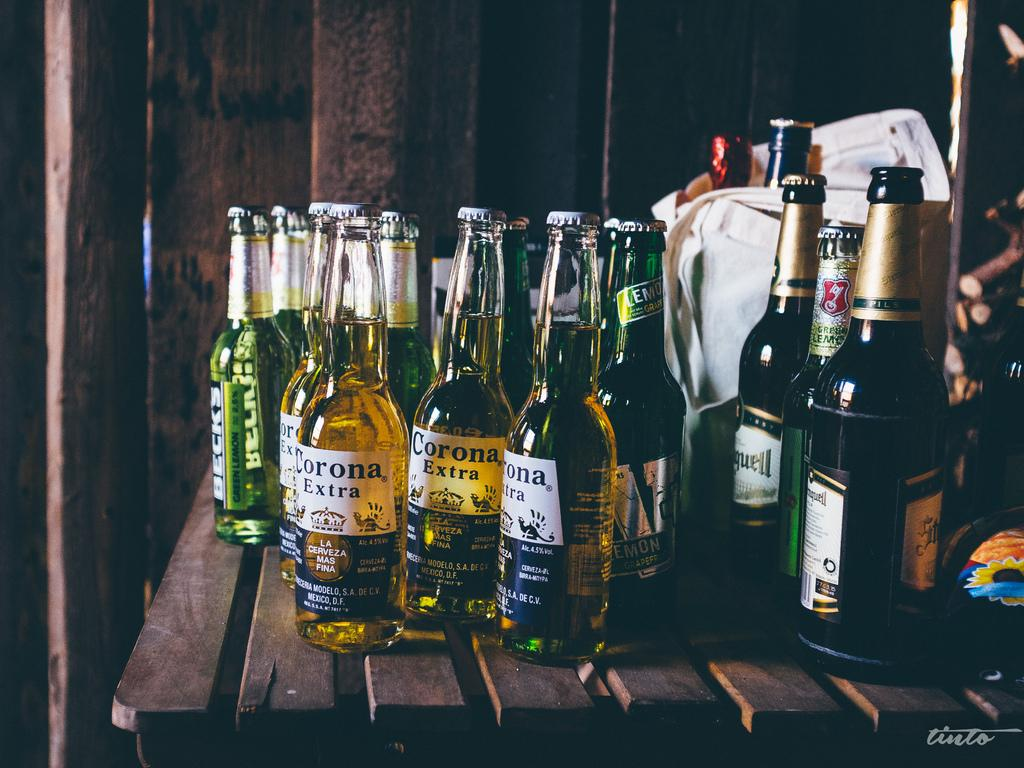<image>
Give a short and clear explanation of the subsequent image. A variety of beer bottles sit together, including Corona and Beck. 